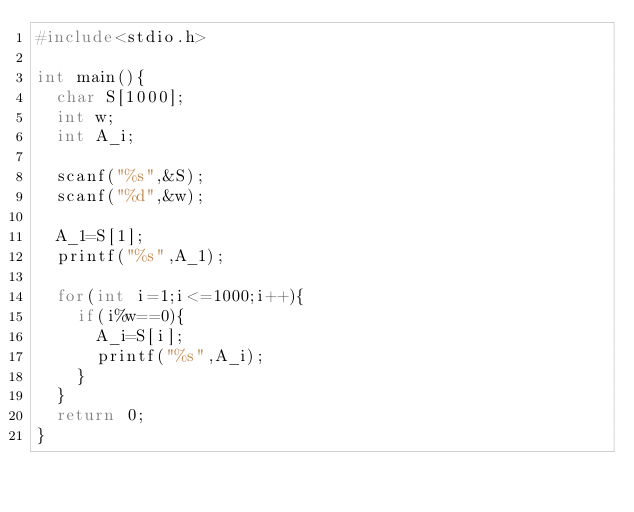Convert code to text. <code><loc_0><loc_0><loc_500><loc_500><_C_>#include<stdio.h>

int main(){
  char S[1000];
  int w;
  int A_i;
  
  scanf("%s",&S);
  scanf("%d",&w);
  
  A_1=S[1];
  printf("%s",A_1);
  
  for(int i=1;i<=1000;i++){
    if(i%w==0){
      A_i=S[i];
      printf("%s",A_i);
    }
  }
  return 0;
}</code> 